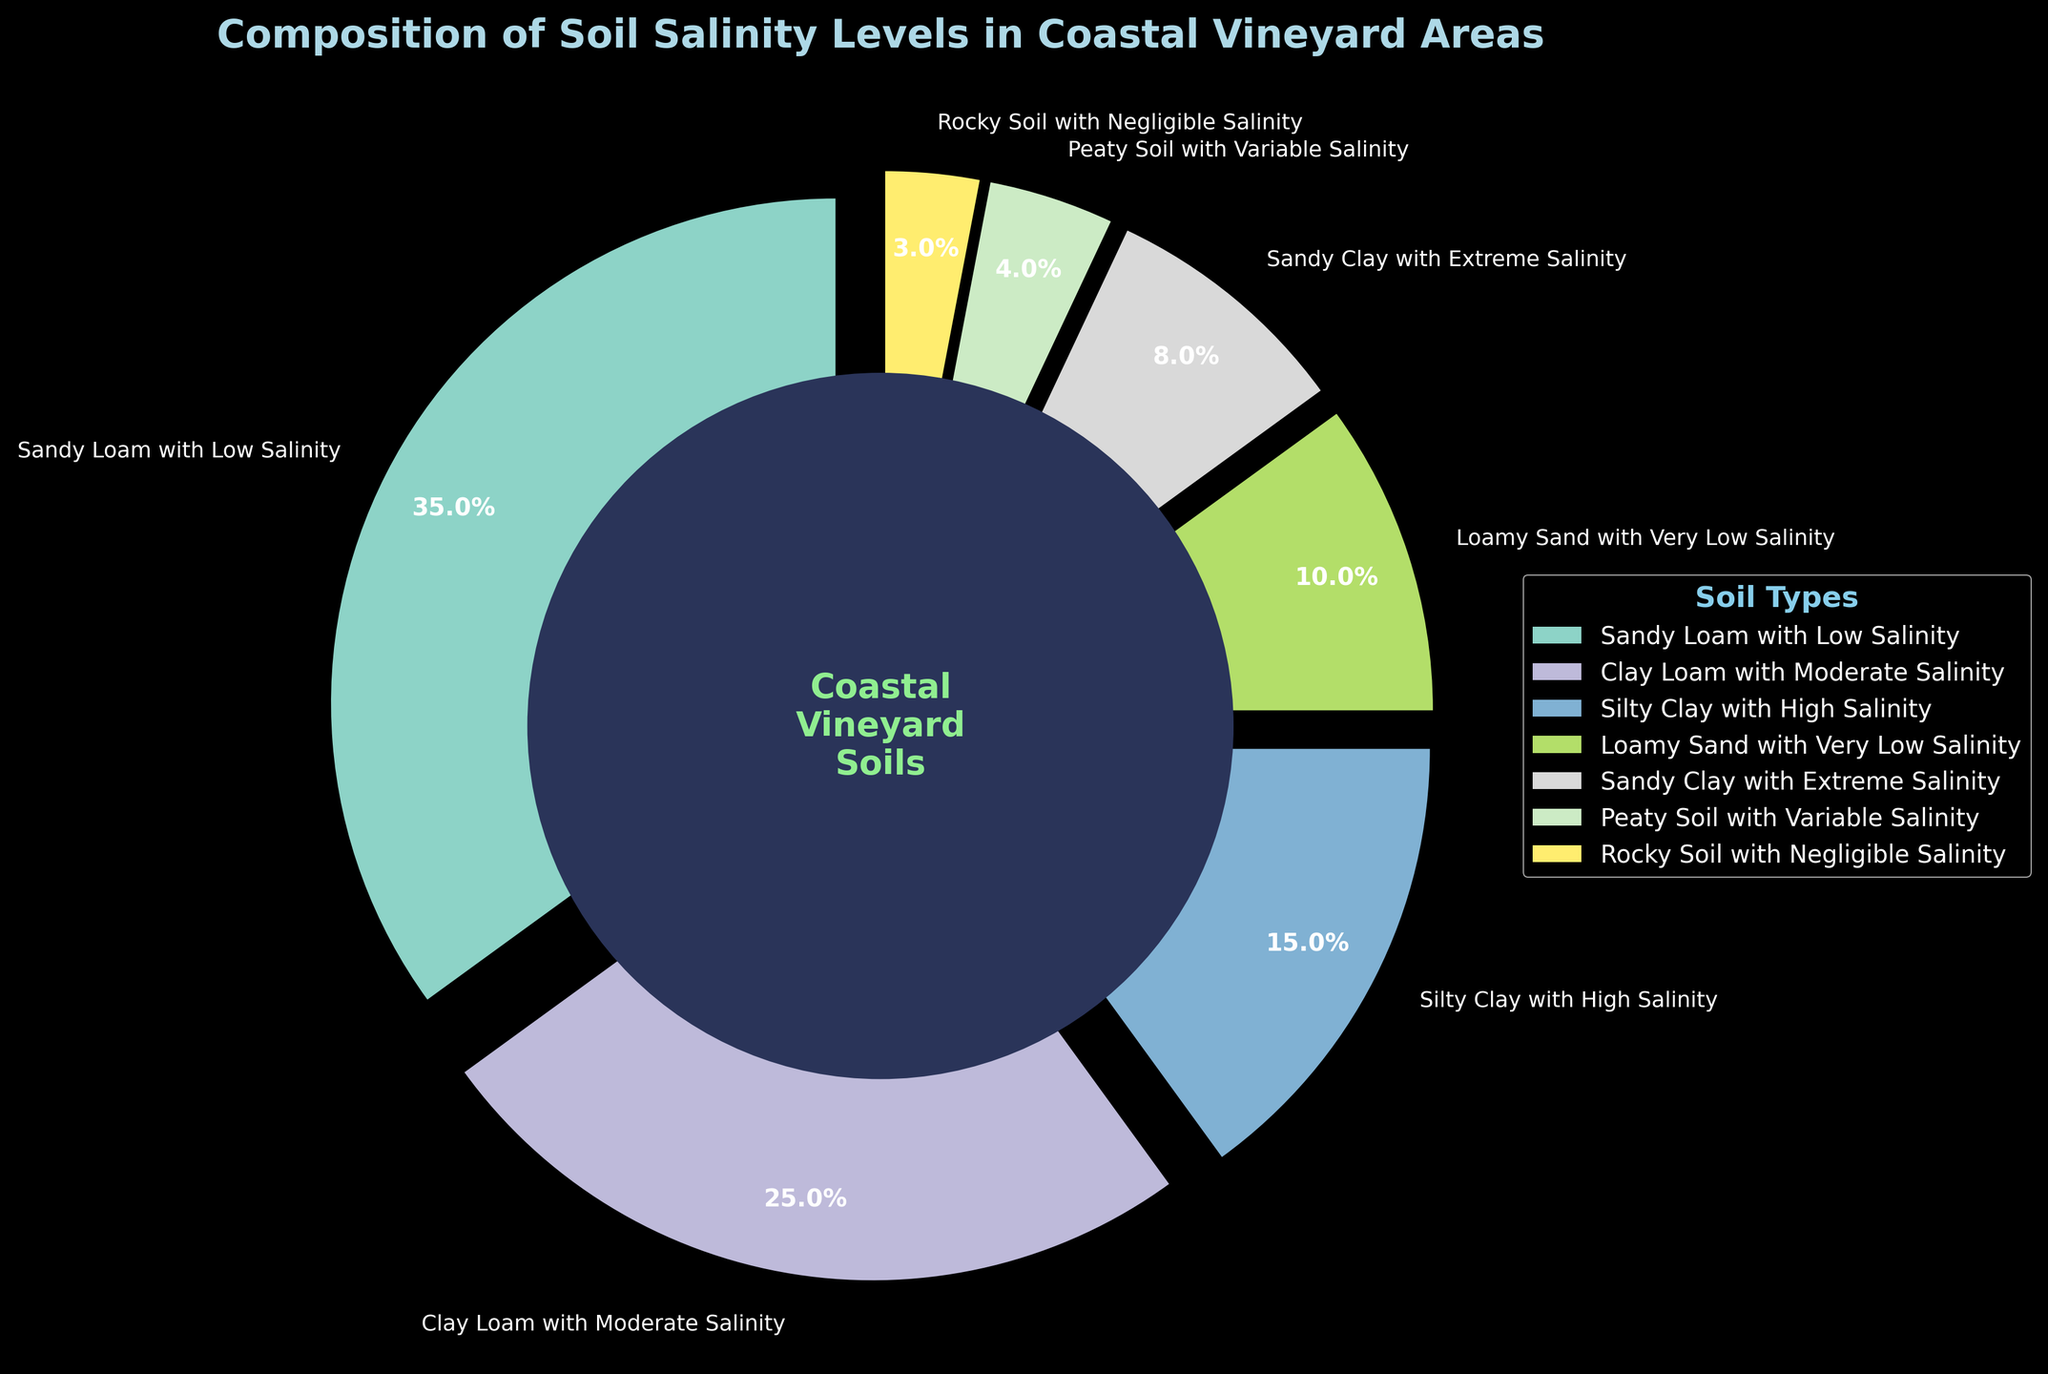What is the total percentage of soil types with low or very low salinity? Add the percentage of "Sandy Loam with Low Salinity" (35%) and "Loamy Sand with Very Low Salinity" (10%), which gives 35% + 10%.
Answer: 45% Which soil type has the highest percentage in the vineyard areas? The label with the highest percentage given in the chart is "Sandy Loam with Low Salinity" at 35%.
Answer: Sandy Loam with Low Salinity How does the percentage of "Clay Loam with Moderate Salinity" compare to "Silty Clay with High Salinity"? The percentage of "Clay Loam with Moderate Salinity" is 25%, which is greater than the 15% of "Silty Clay with High Salinity".
Answer: Greater What is the combined percentage of soil types with salinity levels marked as moderate or higher? Combine "Clay Loam with Moderate Salinity" (25%), "Silty Clay with High Salinity" (15%), "Sandy Clay with Extreme Salinity" (8%), and "Peaty Soil with Variable Salinity" (4%). Calculate: 25% + 15% + 8% + 4% = 52%.
Answer: 52% Which soil type occupies the smallest area in the vineyard regions? The smallest segment shown in the chart is "Rocky Soil with Negligible Salinity" at 3%.
Answer: Rocky Soil with Negligible Salinity How much larger is the percentage of "Loamy Sand with Very Low Salinity" compared to "Peaty Soil with Variable Salinity"? "Loamy Sand with Very Low Salinity" is 10% and "Peaty Soil with Variable Salinity" is 4%. The difference is 10% - 4%.
Answer: 6% What is the visual characteristic of the segment with "Sandy Clay with Extreme Salinity"? This segment is labeled as "Sandy Clay with Extreme Salinity", and an important visual detail is that it is slightly exploded from the pie chart.
Answer: Exploded Can you find the percentage difference between the soil type with the highest salinity and the one with the lowest salinity? The highest salinity is for "Sandy Clay with Extreme Salinity" (8%) and the lowest is "Rocky Soil with Negligible Salinity" (3%). The difference is 8% - 3%.
Answer: 5% What percentage of soils in coastal vineyard areas have more than 15% salinity level? Identify soil types with salinity above 15%: None of the types surpass 15%, as the highest is "Clay Loam with Moderate Salinity" at 25%, which falls within the required range.
Answer: 0% 